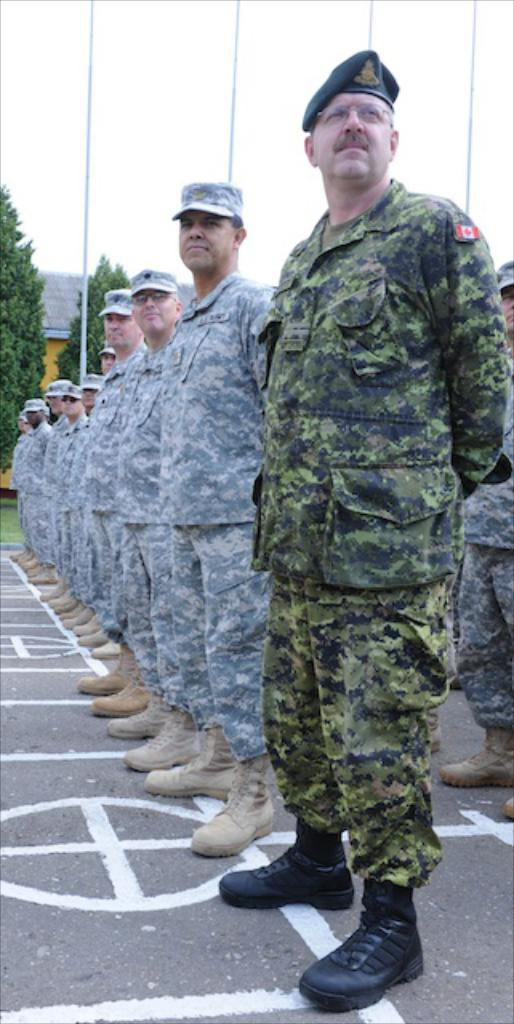What is the man on the right side of the road doing? The man is standing on the right side of the road. What is the man wearing? The man is wearing a green dress. Are there any other people in the image? Yes, there is a group of people standing in a line beside the man. What can be seen at the top of the image? The sky is visible at the top of the image. What type of cream is being used to decorate the man's green dress in the image? There is no cream visible on the man's green dress in the image. Are there any jewels or precious stones adorning the man's green dress in the image? There is no mention of jewels or precious stones in the description of the man's green dress in the image. 